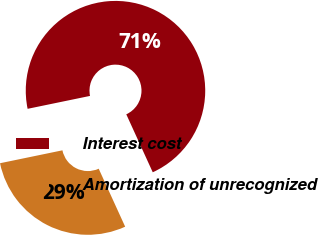Convert chart to OTSL. <chart><loc_0><loc_0><loc_500><loc_500><pie_chart><fcel>Interest cost<fcel>Amortization of unrecognized<nl><fcel>71.43%<fcel>28.57%<nl></chart> 